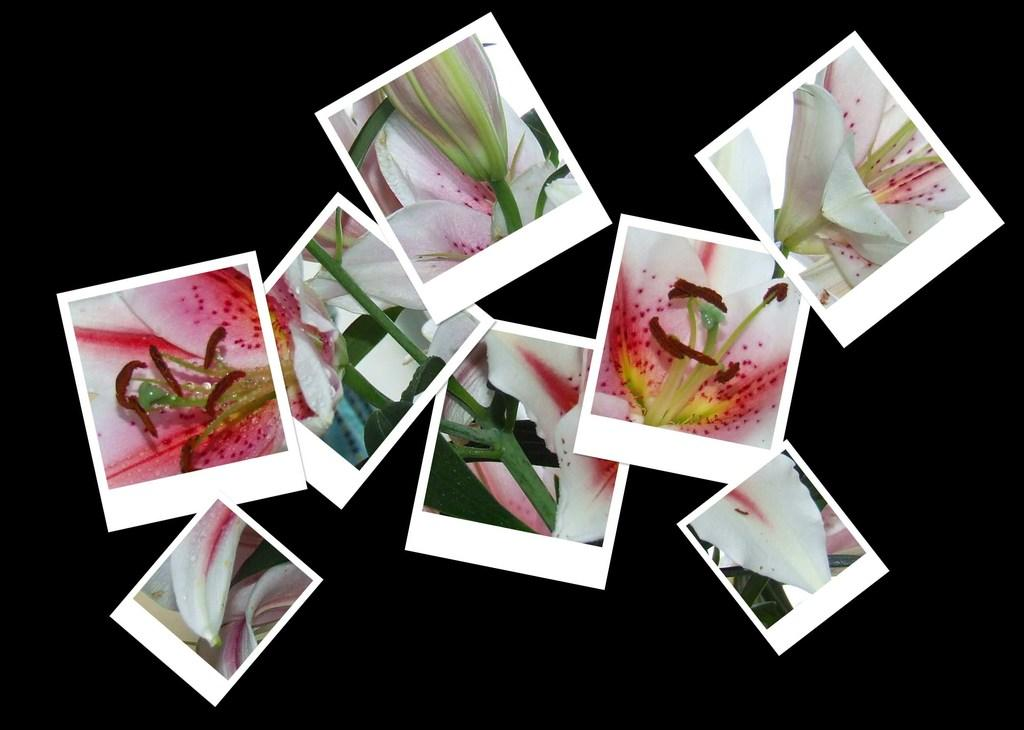What is the main subject of the image? The main subject of the image is many pictures. What do the pictures contain? The pictures contain parts of flowers. How would you describe the overall appearance of the image? The background of the image is dark. How many pets are visible in the image? There are no pets present in the image; it contains pictures of flower parts. What type of brush is used to create the images? There is no information about the type of brush used to create the images, as the focus is on the content of the pictures and the overall appearance of the image. 